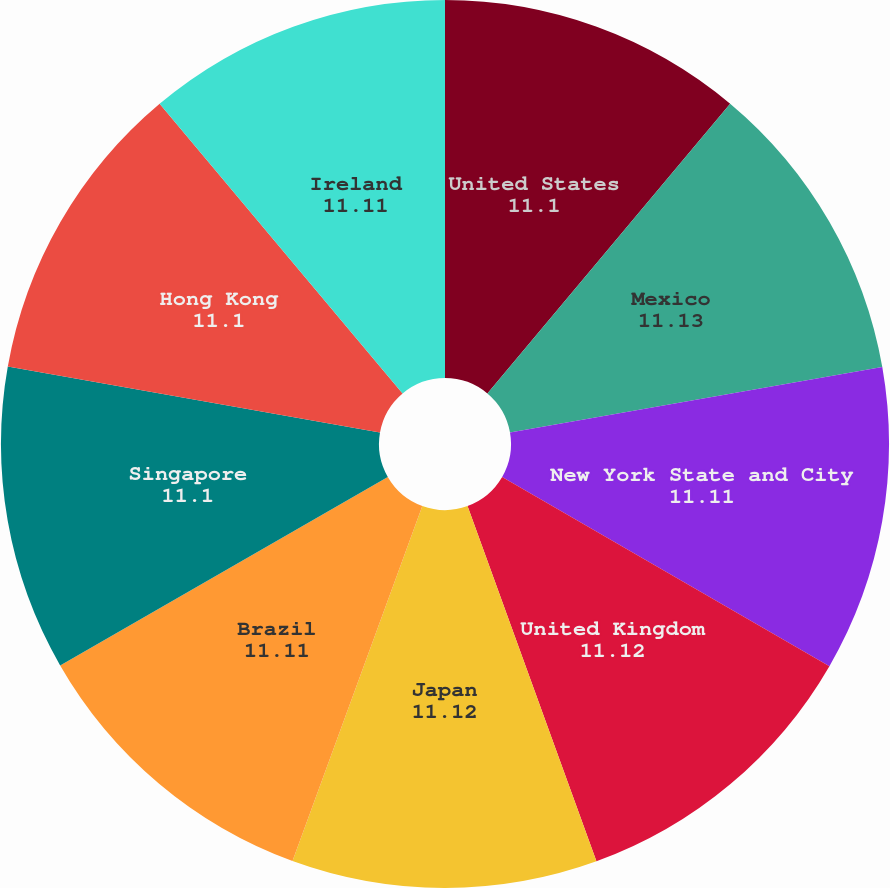<chart> <loc_0><loc_0><loc_500><loc_500><pie_chart><fcel>United States<fcel>Mexico<fcel>New York State and City<fcel>United Kingdom<fcel>Japan<fcel>Brazil<fcel>Singapore<fcel>Hong Kong<fcel>Ireland<nl><fcel>11.1%<fcel>11.13%<fcel>11.11%<fcel>11.12%<fcel>11.12%<fcel>11.11%<fcel>11.1%<fcel>11.1%<fcel>11.11%<nl></chart> 